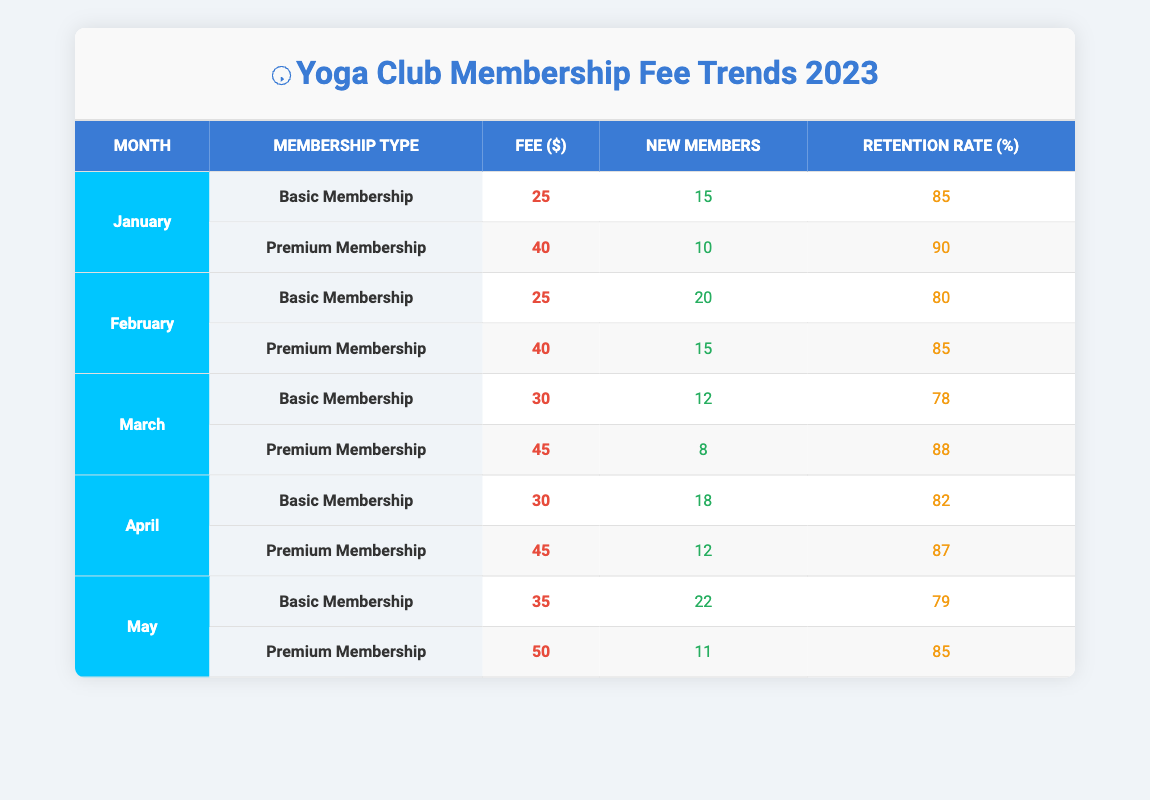What's the fee for Basic Membership in March? The table shows that the fee for Basic Membership in March is specified in the corresponding row under March for Basic Membership. It states "30" under the Fee column.
Answer: 30 How many new members joined in February for Premium Membership? The table indicates that in February, Premium Membership had 15 new members, which can be found in the row for February under Premium Membership.
Answer: 15 What is the retention rate for Basic Membership in May? According to the table, the retention rate for Basic Membership in May is found in the row for May under Basic Membership, which states "79".
Answer: 79 Which month had the highest fee for Premium Membership? To find this, we check the fees for Premium Membership across all months. They are 40, 40, 45, 45, and 50 for January, February, March, April, and May, respectively. May has the highest fee of 50.
Answer: May Was the retention rate for Basic Membership greater than 80% in any month? We need to check the retention rates for Basic Membership. The rates are 85, 80, 78, 82, and 79 for January to May. Only January (85) and April (82) are greater than 80%.
Answer: Yes What was the average retention rate for Premium Membership from January to May? We first find the retention rates for Premium Membership, which are 90, 85, 88, 87, and 85. We sum these values: 90 + 85 + 88 + 87 + 85 = 435. Since there are 5 months, we calculate the average: 435 / 5 = 87.
Answer: 87 How many new members were there for Basic Membership in April? The table shows that in April, for Basic Membership, the number of new members is listed as 18 in the corresponding row.
Answer: 18 Is the fee for Premium Membership consistent across the first three months? The fees for Premium Membership in the first three months are 40, 40, and 45, indicating that while the first two months are consistent at 40, March is different at 45. Therefore, they are not consistent.
Answer: No Which month experienced the highest total new members across both membership types? We check the new members for each month: January (15 + 10 = 25), February (20 + 15 = 35), March (12 + 8 = 20), April (18 + 12 = 30), and May (22 + 11 = 33). The highest total is in February with 35 new members.
Answer: February 